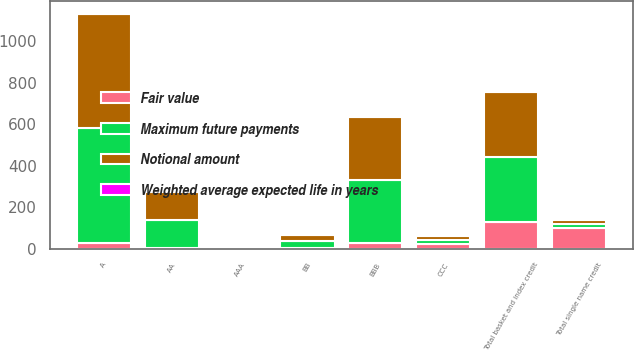Convert chart. <chart><loc_0><loc_0><loc_500><loc_500><stacked_bar_chart><ecel><fcel>AAA<fcel>AA<fcel>A<fcel>BBB<fcel>BB<fcel>Total single name credit<fcel>CCC<fcel>Total basket and index credit<nl><fcel>Notional amount<fcel>10<fcel>135<fcel>554<fcel>305<fcel>33<fcel>20<fcel>20<fcel>315<nl><fcel>Fair value<fcel>1<fcel>4.6<fcel>25.8<fcel>24.4<fcel>1.4<fcel>98.2<fcel>20<fcel>125.9<nl><fcel>Maximum future payments<fcel>10<fcel>135<fcel>554<fcel>305<fcel>33<fcel>20<fcel>20<fcel>315<nl><fcel>Weighted average expected life in years<fcel>4.5<fcel>5.4<fcel>4.8<fcel>2.7<fcel>0.5<fcel>4.4<fcel>3<fcel>3<nl></chart> 